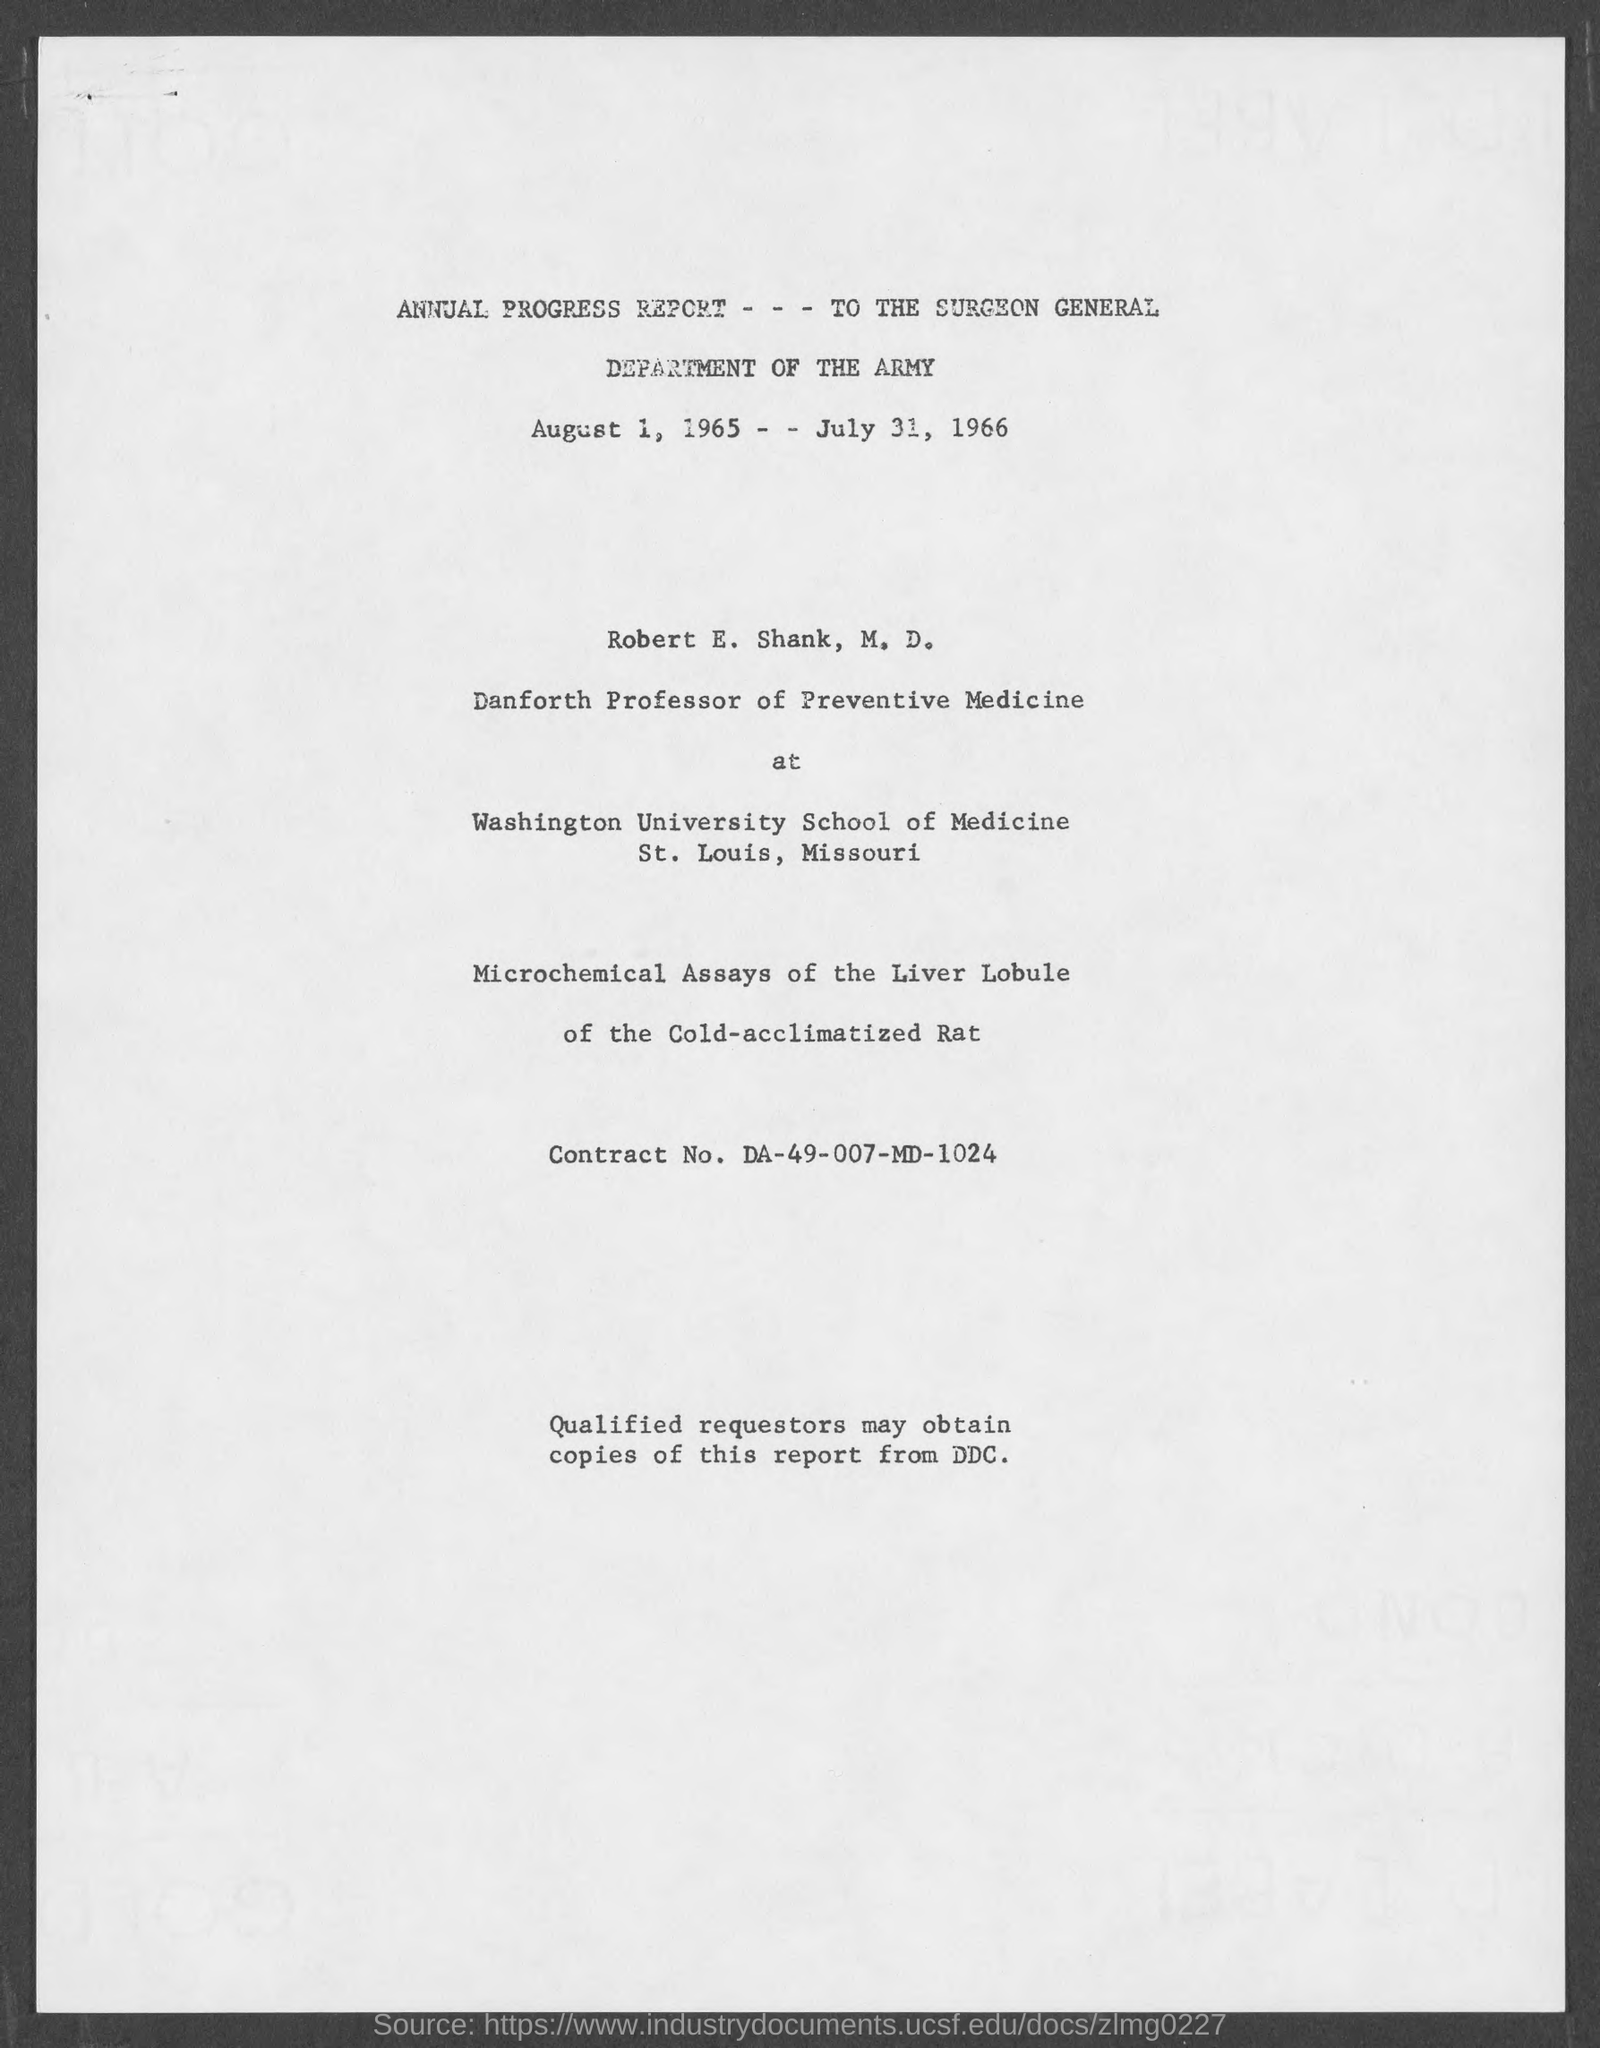What is the contract no.?
Ensure brevity in your answer.  DA-49-007-MD-1024. What is the position of robert e. shank, m.d.?
Ensure brevity in your answer.  Danforth Professor of Preventive Medicine. 